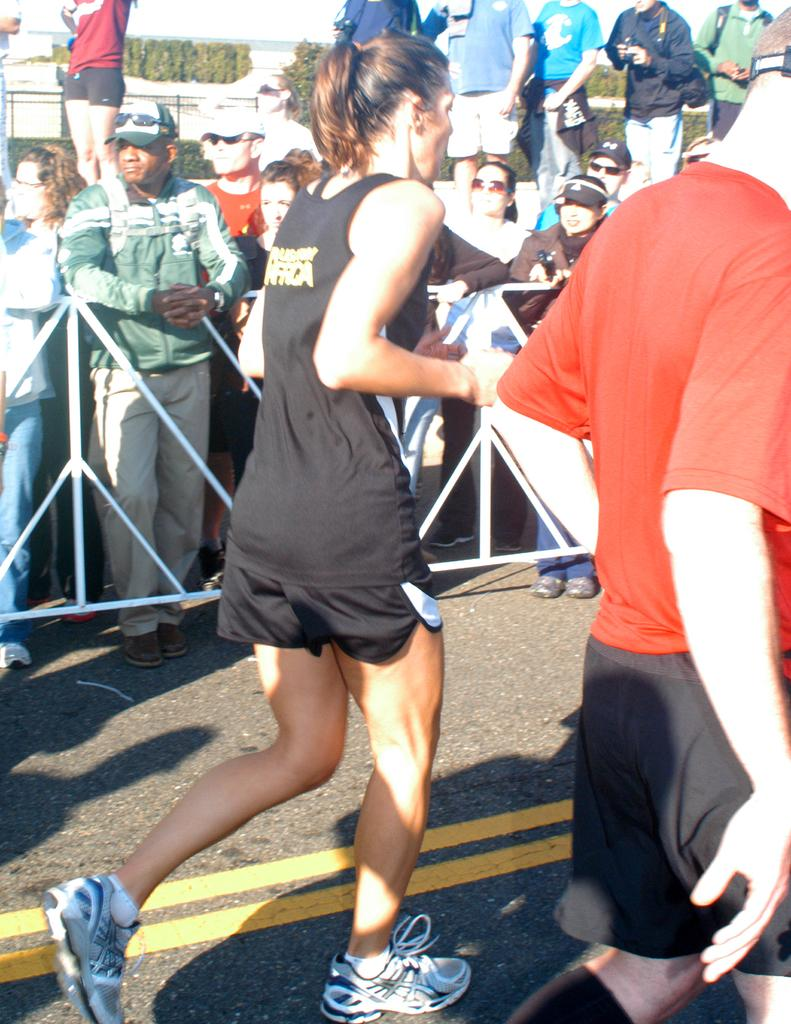What are the two main subjects in the image doing? There is a lady running and a man running in the image. Can you describe the background of the image? There are people standing in the background of the image, and there are trees visible as well. Is the lady running into any quicksand in the image? There is no quicksand present in the image. What class are the people in the background attending? There is no indication of a class or any educational setting in the image. 